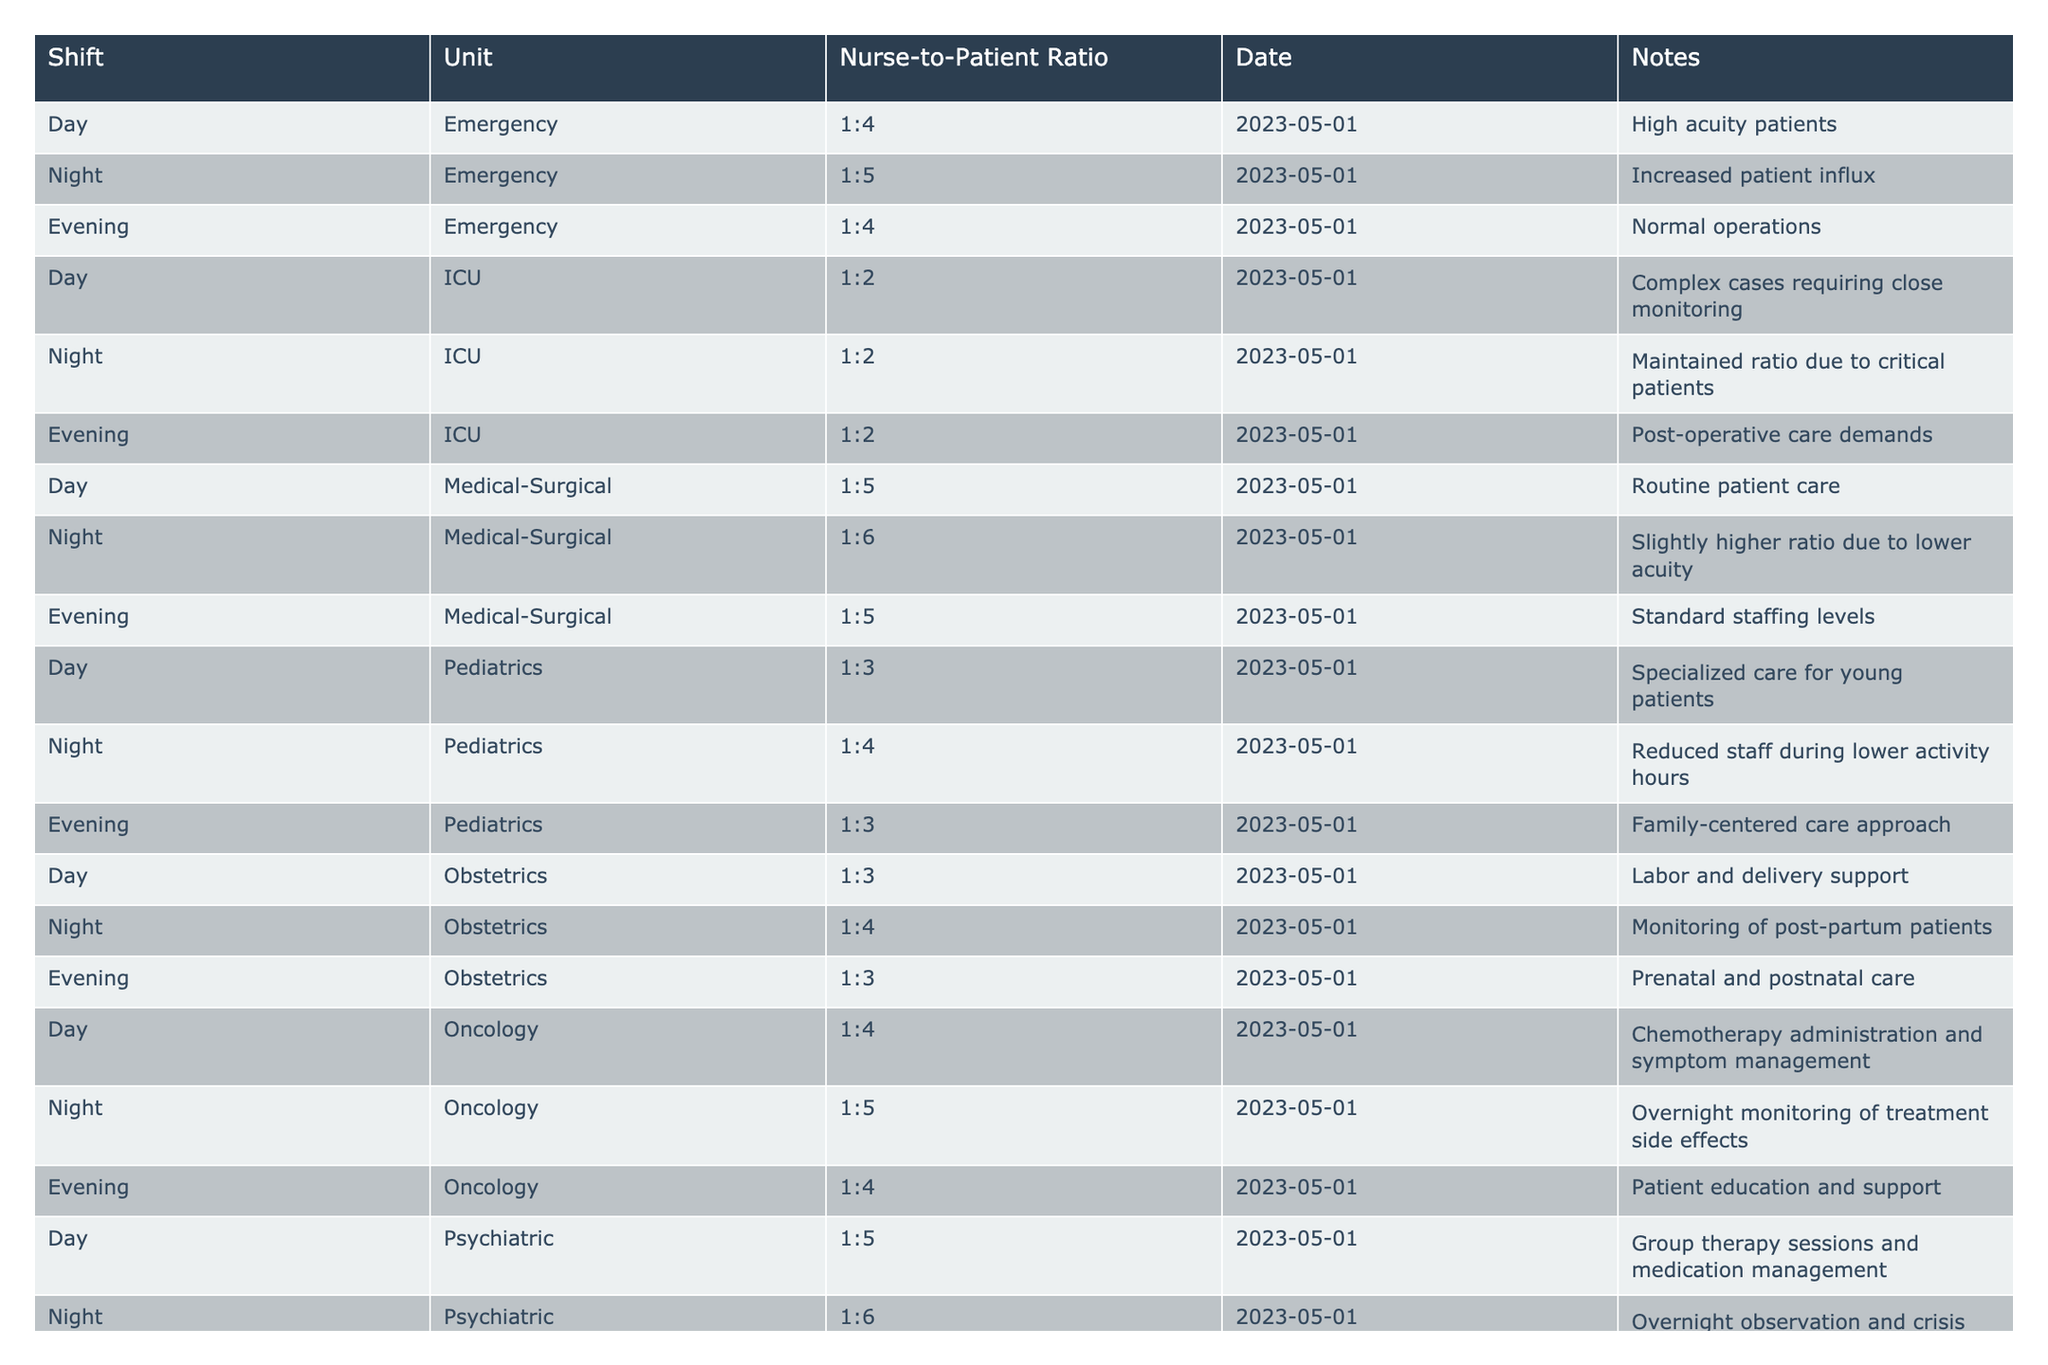What is the nurse-to-patient ratio for the ICU during the night shift? In the table, the row corresponding to the ICU during the night shift shows the nurse-to-patient ratio as 1:2.
Answer: 1:2 How many different units are listed in the table? By examining the 'Unit' column, we can see the unique units mentioned: Emergency, ICU, Medical-Surgical, Pediatrics, Obstetrics, Oncology, and Psychiatric, which totals to 7.
Answer: 7 Which shift has the highest nurse-to-patient ratio in the Medical-Surgical unit? In the Medical-Surgical unit, the night shift has the highest nurse-to-patient ratio listed as 1:6, compared to 1:5 in both day and evening shifts.
Answer: 1:6 Is the nurse-to-patient ratio in the Emergency unit during the day the same as in the evening? The nurse-to-patient ratio in the Emergency unit for both day and evening shifts is 1:4, meaning they are the same.
Answer: Yes What is the average nurse-to-patient ratio across all shifts for the Pediatrics unit? The ratios for Pediatrics are 1:3 (Day), 1:4 (Night), and 1:3 (Evening). To find the average, convert to decimal (0.33, 0.25, 0.33), sum to get 0.91, and divide by 3, resulting in an average of approximately 0.30, which we convert back to the ratio 1:3.
Answer: 1:3 Which unit has a consistent nurse-to-patient ratio across all shifts? By reviewing the data, the ICU unit has a consistent ratio of 1:2 across all its shifts (Day, Night, Evening), indicating uniform staffing.
Answer: ICU During which shift in the Oncology unit does the ratio decrease? The ratio for the Oncology unit decreases during the night shift from 1:4 (Day) to 1:5 (Night).
Answer: Night How does the nurse-to-patient ratio in the Pediatric unit during the night compare to that in the Obstetrics unit? The Pediatric unit has a nurse-to-patient ratio of 1:4 during the night, while the Obstetrics unit has a ratio of 1:4 as well, indicating they are equal.
Answer: They are equal What is the total number of shifts listed for the Psychiatric unit? There are three entries for the Psychiatric unit: Day, Night, and Evening, thus totaling three shifts.
Answer: 3 For which unit and shift is the nurse-to-patient ratio at its best (lowest number indicating fewer patients per nurse)? The ICU unit during any shift (Day, Night, Evening) has the best ratio, which is 1:2, indicating fewer patients assigned per nurse.
Answer: ICU, all shifts 